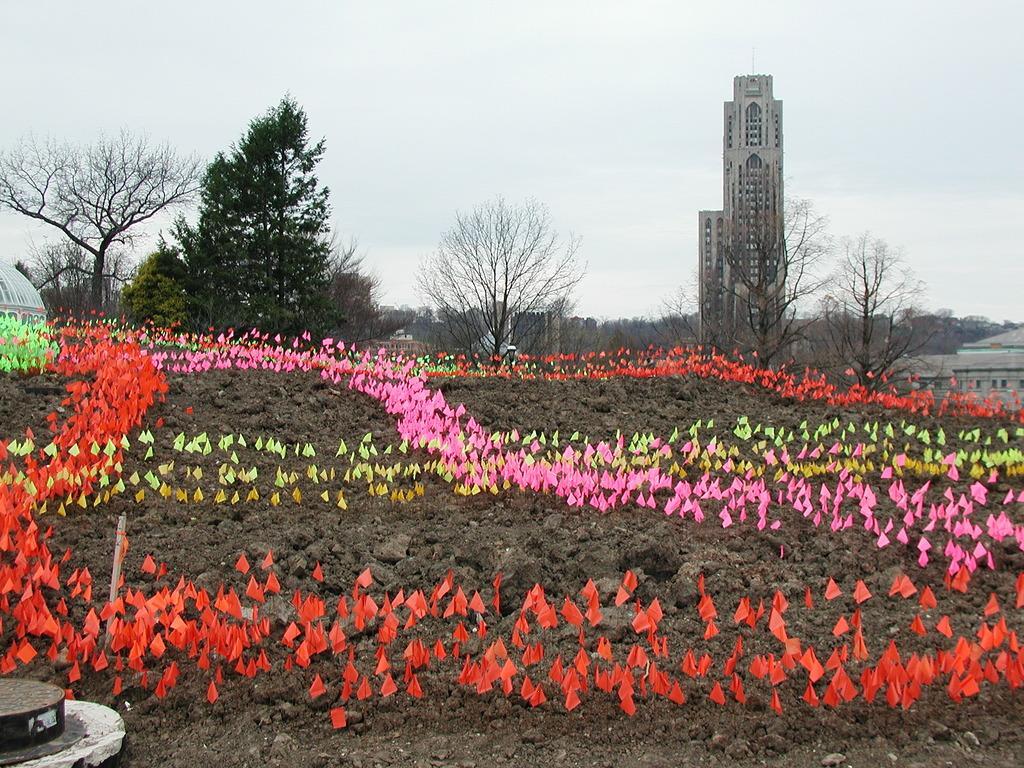Could you give a brief overview of what you see in this image? In this picture I can see an object in the bottom left hand side, in the middle those are looking like the papers in different colors. In the background I can see few trees and buildings, at the top there is the sky. 